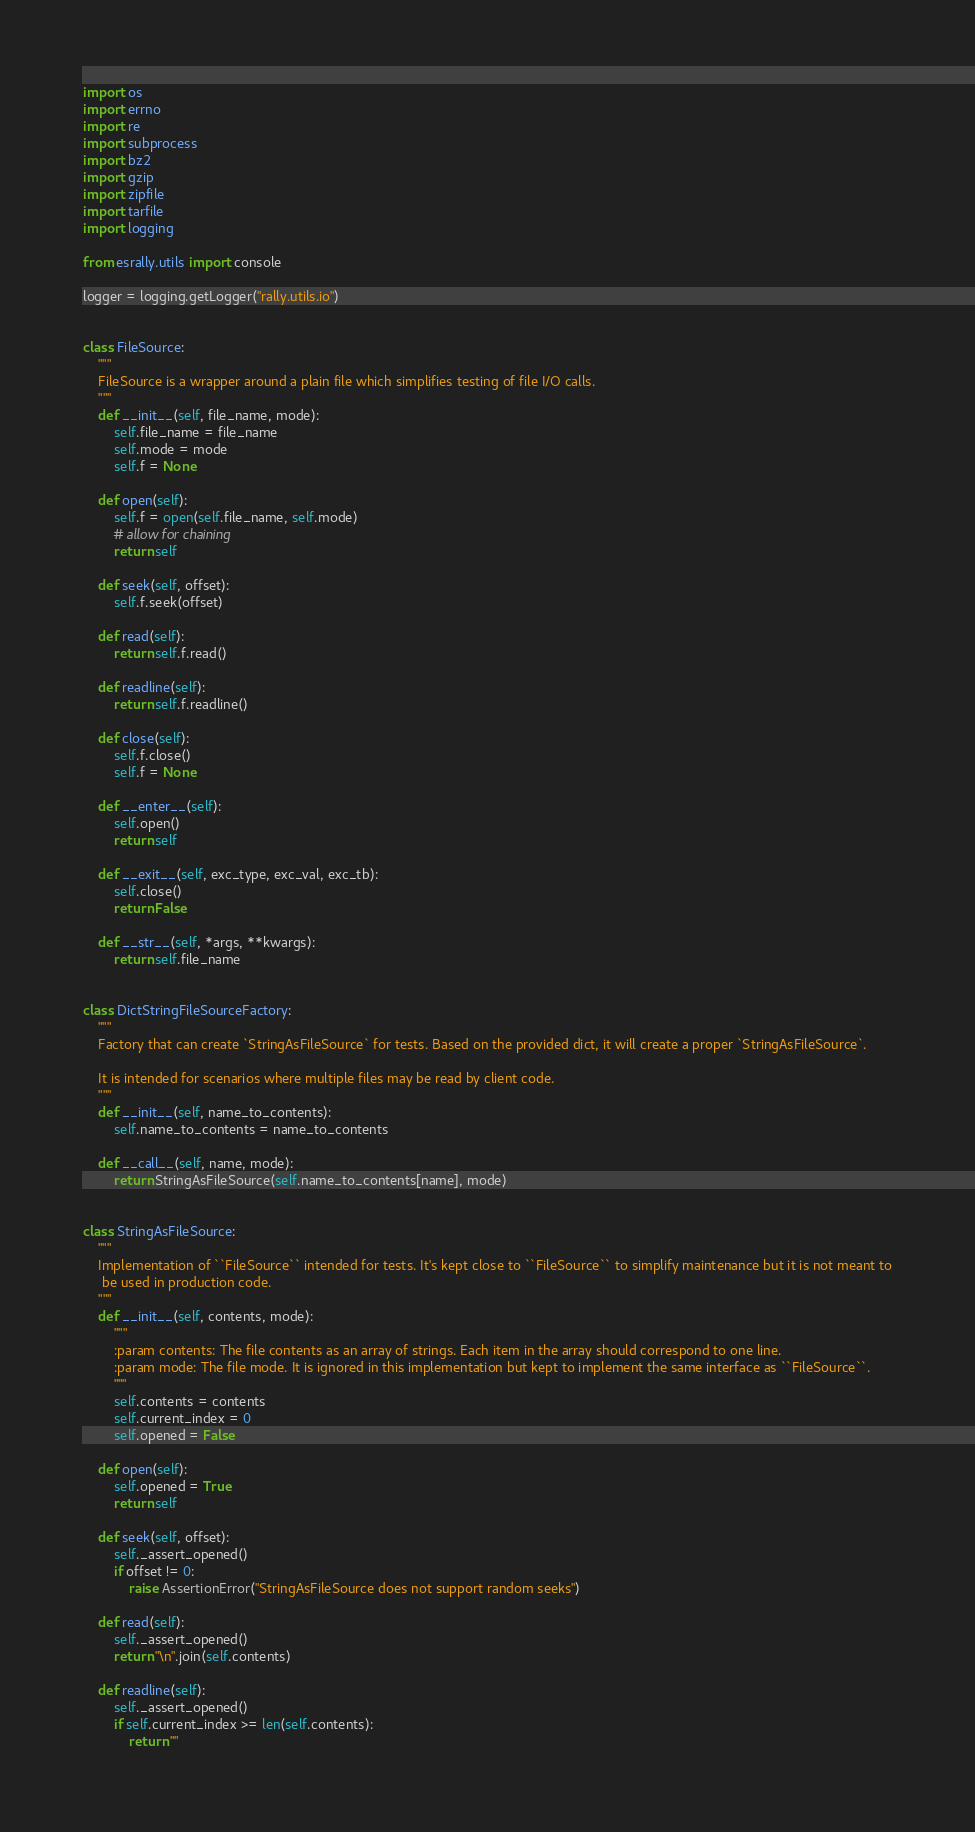Convert code to text. <code><loc_0><loc_0><loc_500><loc_500><_Python_>import os
import errno
import re
import subprocess
import bz2
import gzip
import zipfile
import tarfile
import logging

from esrally.utils import console

logger = logging.getLogger("rally.utils.io")


class FileSource:
    """
    FileSource is a wrapper around a plain file which simplifies testing of file I/O calls.
    """
    def __init__(self, file_name, mode):
        self.file_name = file_name
        self.mode = mode
        self.f = None

    def open(self):
        self.f = open(self.file_name, self.mode)
        # allow for chaining
        return self

    def seek(self, offset):
        self.f.seek(offset)

    def read(self):
        return self.f.read()

    def readline(self):
        return self.f.readline()

    def close(self):
        self.f.close()
        self.f = None

    def __enter__(self):
        self.open()
        return self

    def __exit__(self, exc_type, exc_val, exc_tb):
        self.close()
        return False

    def __str__(self, *args, **kwargs):
        return self.file_name


class DictStringFileSourceFactory:
    """
    Factory that can create `StringAsFileSource` for tests. Based on the provided dict, it will create a proper `StringAsFileSource`.

    It is intended for scenarios where multiple files may be read by client code.
    """
    def __init__(self, name_to_contents):
        self.name_to_contents = name_to_contents

    def __call__(self, name, mode):
        return StringAsFileSource(self.name_to_contents[name], mode)


class StringAsFileSource:
    """
    Implementation of ``FileSource`` intended for tests. It's kept close to ``FileSource`` to simplify maintenance but it is not meant to
     be used in production code.
    """
    def __init__(self, contents, mode):
        """
        :param contents: The file contents as an array of strings. Each item in the array should correspond to one line.
        :param mode: The file mode. It is ignored in this implementation but kept to implement the same interface as ``FileSource``.
        """
        self.contents = contents
        self.current_index = 0
        self.opened = False

    def open(self):
        self.opened = True
        return self

    def seek(self, offset):
        self._assert_opened()
        if offset != 0:
            raise AssertionError("StringAsFileSource does not support random seeks")

    def read(self):
        self._assert_opened()
        return "\n".join(self.contents)

    def readline(self):
        self._assert_opened()
        if self.current_index >= len(self.contents):
            return ""</code> 